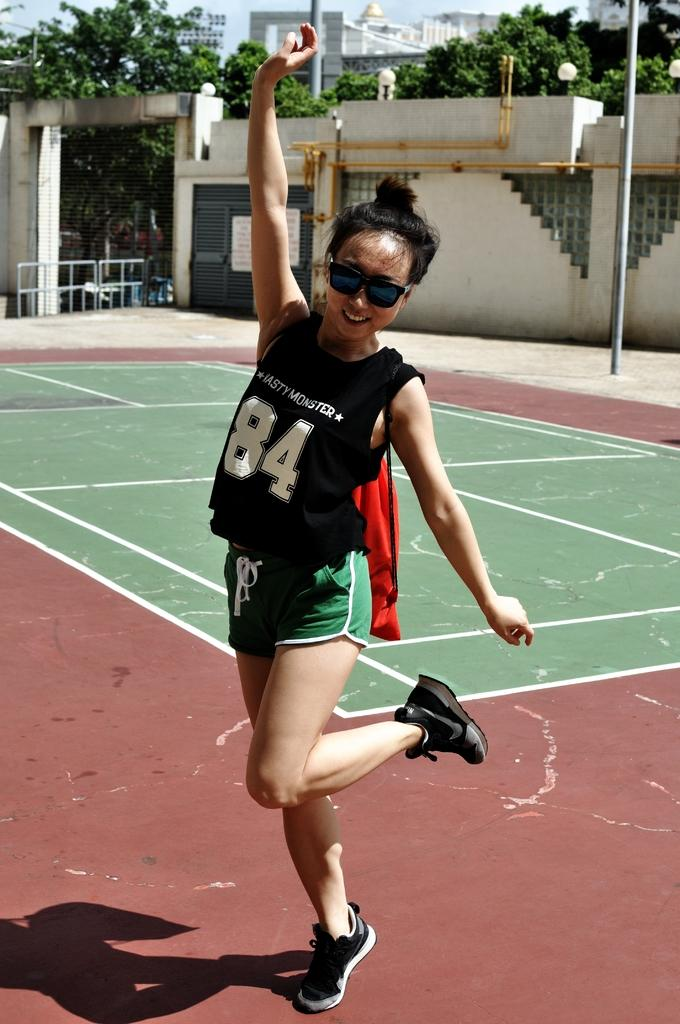Provide a one-sentence caption for the provided image. A young girl with a team jersey on that says Nasty Monster. 